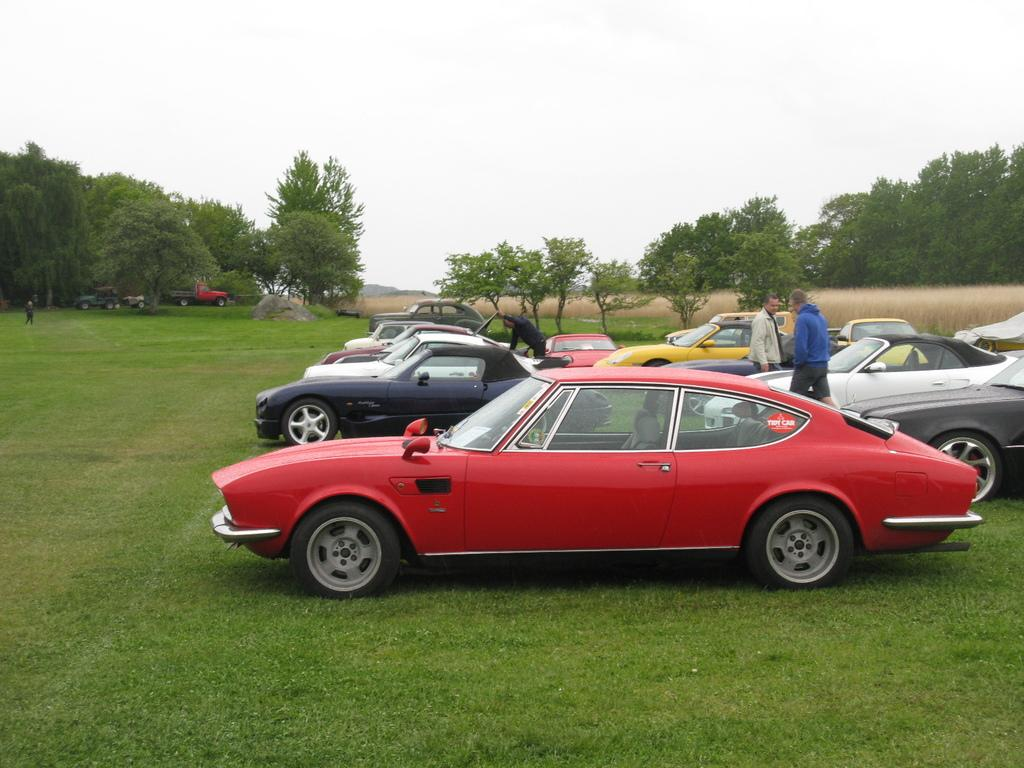What type of vehicles can be seen in the image? There are cars in the image. Who or what else is present in the image besides the cars? There are people in the image. Where are the cars and people located in the image? The cars and people are on the ground. What can be seen in the background of the image? There are trees and the sky visible in the background of the image. What type of leather is being used by the queen in the image? There is no queen or leather present in the image. Can you describe the elbow of the person in the image? There is no specific person or body part mentioned in the image, so it is not possible to describe an elbow. 